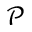Convert formula to latex. <formula><loc_0><loc_0><loc_500><loc_500>\mathcal { P }</formula> 